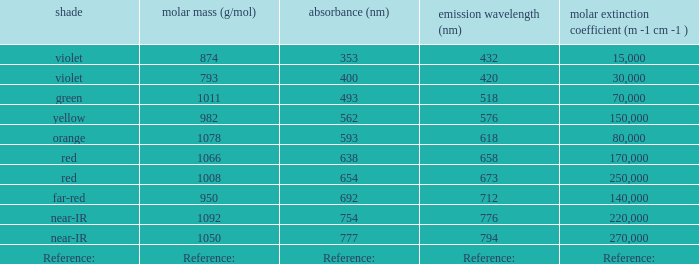Which ε (M -1 cm -1) has a molar mass of 1008 g/mol? 250000.0. 